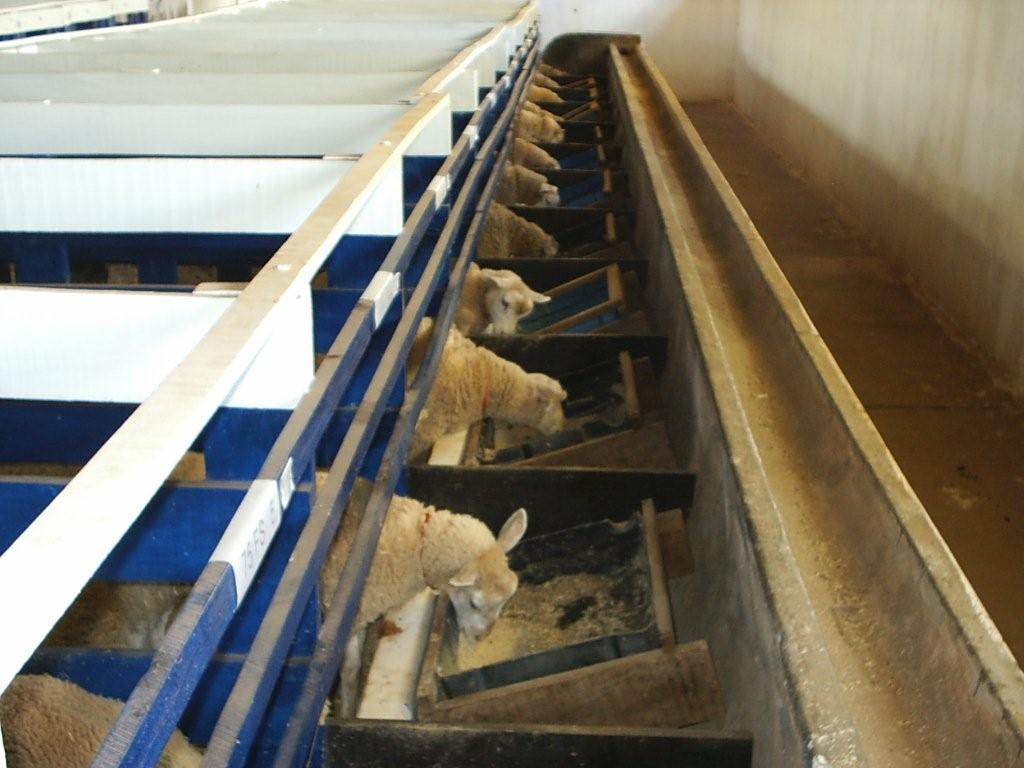In one or two sentences, can you explain what this image depicts? This image is taken in a sheep farm, where we can see sheep eating and few trays. On the right, there is a path. 